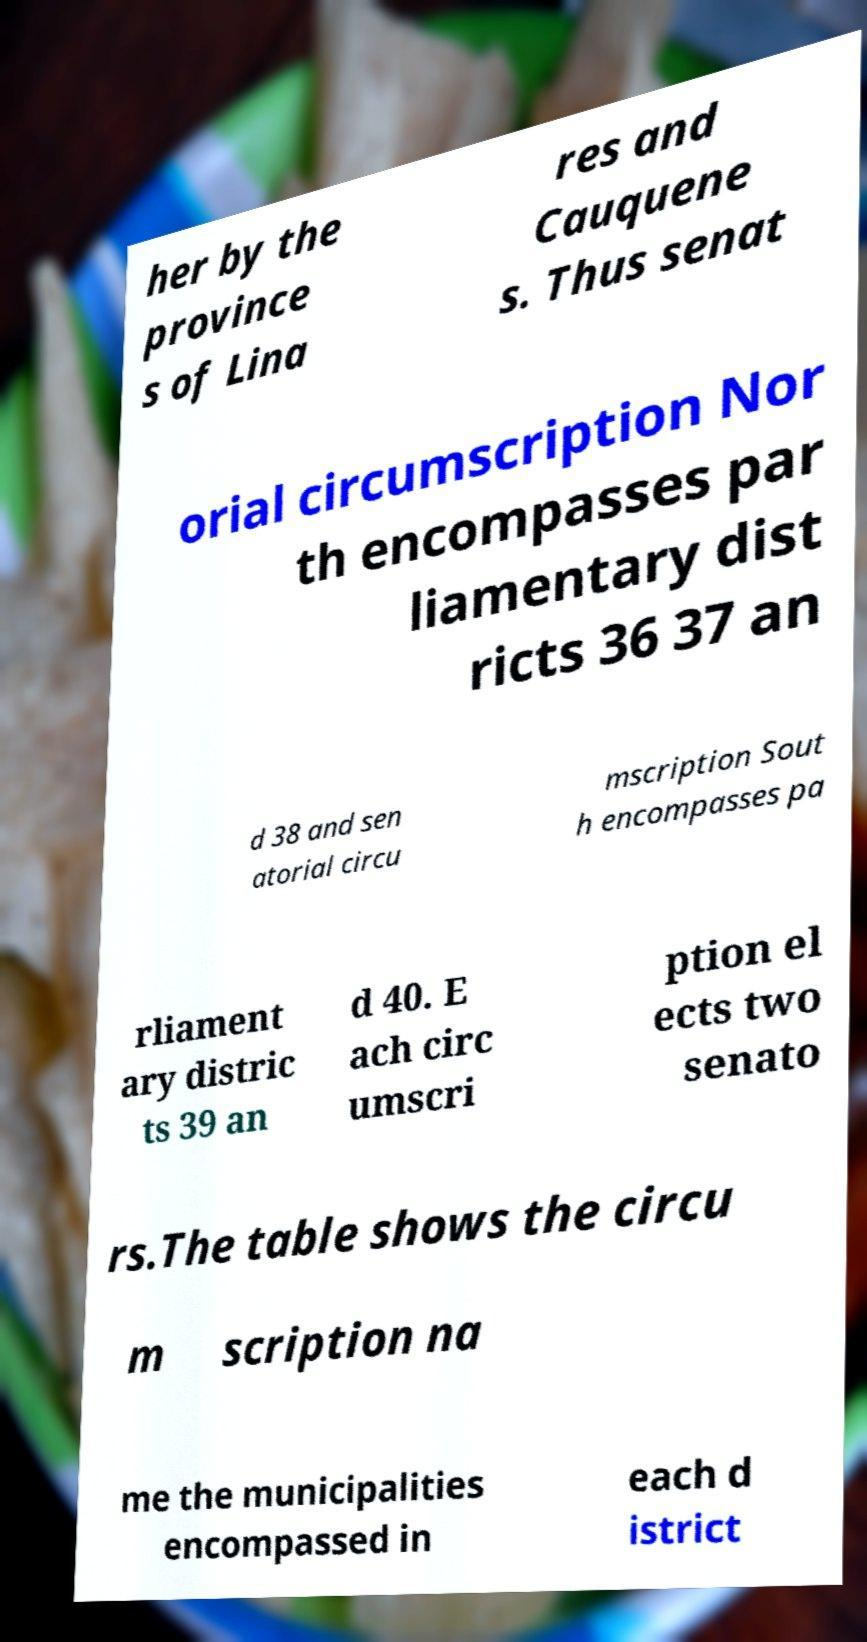Could you assist in decoding the text presented in this image and type it out clearly? her by the province s of Lina res and Cauquene s. Thus senat orial circumscription Nor th encompasses par liamentary dist ricts 36 37 an d 38 and sen atorial circu mscription Sout h encompasses pa rliament ary distric ts 39 an d 40. E ach circ umscri ption el ects two senato rs.The table shows the circu m scription na me the municipalities encompassed in each d istrict 